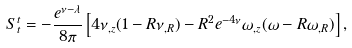Convert formula to latex. <formula><loc_0><loc_0><loc_500><loc_500>S ^ { t } _ { t } = - \frac { e ^ { \nu - \lambda } } { 8 \pi } \left [ 4 \nu _ { , z } ( 1 - { R } \nu _ { , { R } } ) - { R } ^ { 2 } e ^ { - 4 \nu } \omega _ { , z } ( \omega - { R } \omega _ { , { R } } ) \right ] ,</formula> 